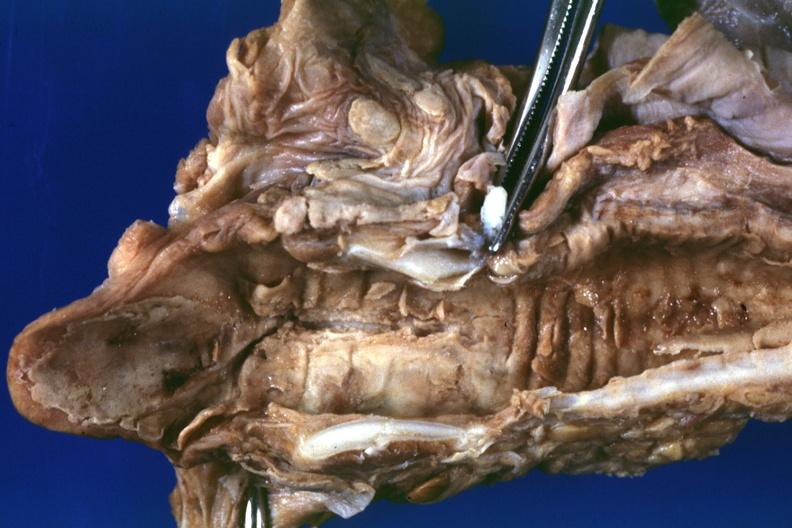s extremities present?
Answer the question using a single word or phrase. No 